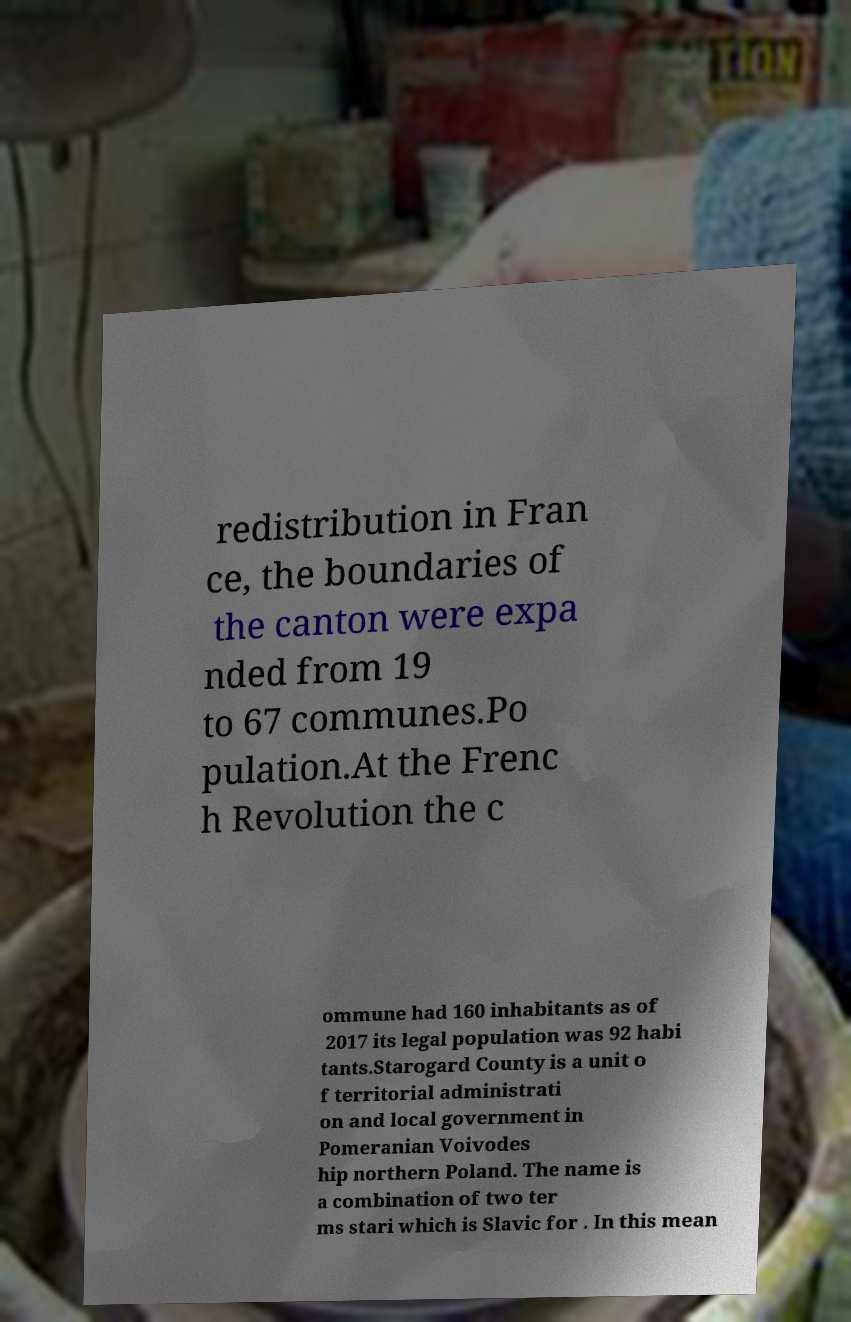What messages or text are displayed in this image? I need them in a readable, typed format. redistribution in Fran ce, the boundaries of the canton were expa nded from 19 to 67 communes.Po pulation.At the Frenc h Revolution the c ommune had 160 inhabitants as of 2017 its legal population was 92 habi tants.Starogard County is a unit o f territorial administrati on and local government in Pomeranian Voivodes hip northern Poland. The name is a combination of two ter ms stari which is Slavic for . In this mean 